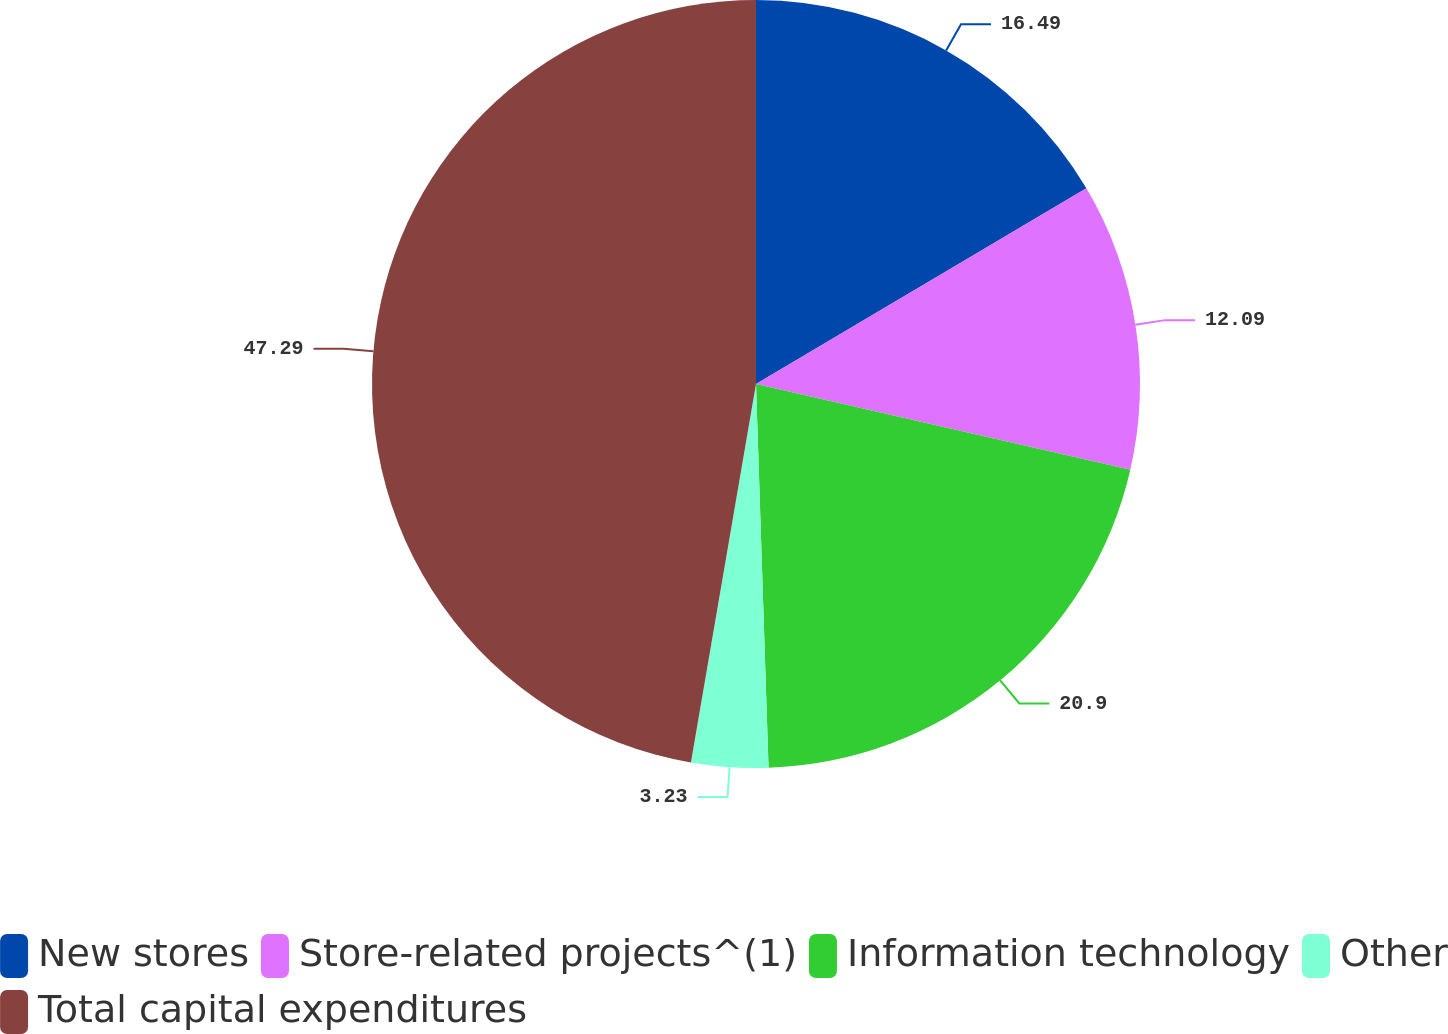Convert chart. <chart><loc_0><loc_0><loc_500><loc_500><pie_chart><fcel>New stores<fcel>Store-related projects^(1)<fcel>Information technology<fcel>Other<fcel>Total capital expenditures<nl><fcel>16.49%<fcel>12.09%<fcel>20.9%<fcel>3.23%<fcel>47.29%<nl></chart> 